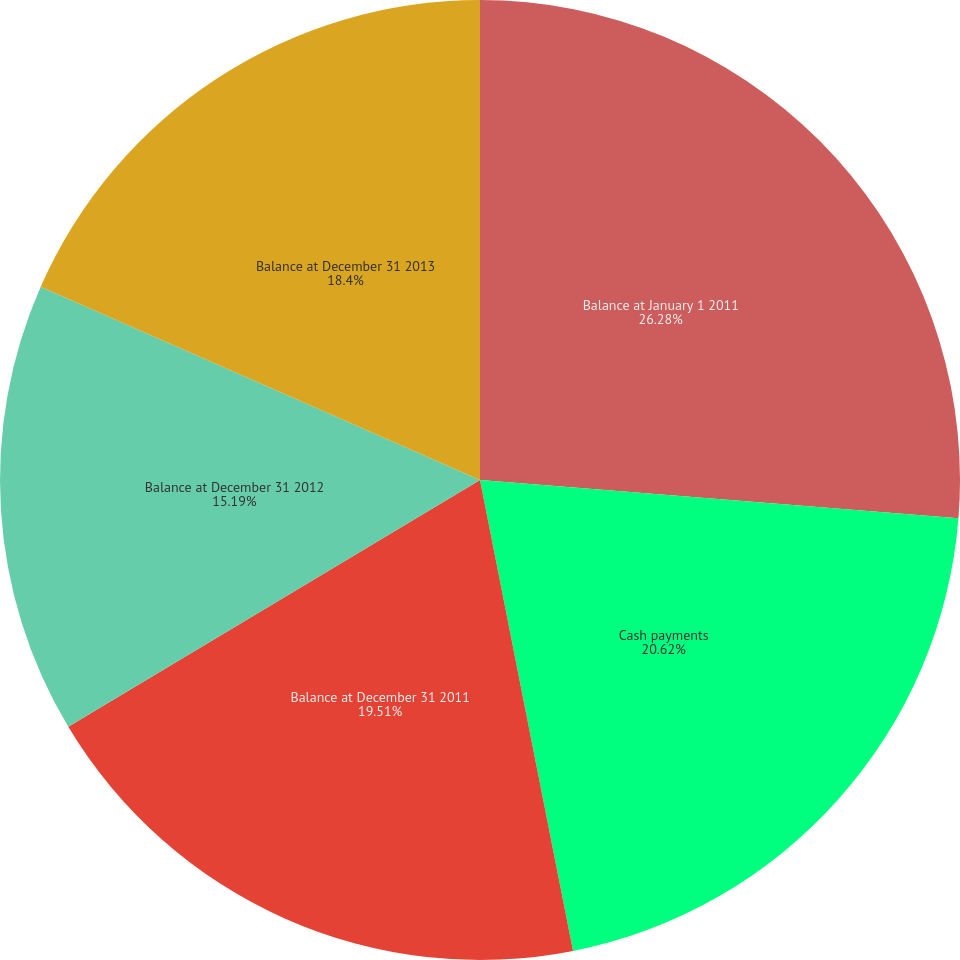Convert chart. <chart><loc_0><loc_0><loc_500><loc_500><pie_chart><fcel>Balance at January 1 2011<fcel>Cash payments<fcel>Balance at December 31 2011<fcel>Balance at December 31 2012<fcel>Balance at December 31 2013<nl><fcel>26.27%<fcel>20.62%<fcel>19.51%<fcel>15.19%<fcel>18.4%<nl></chart> 